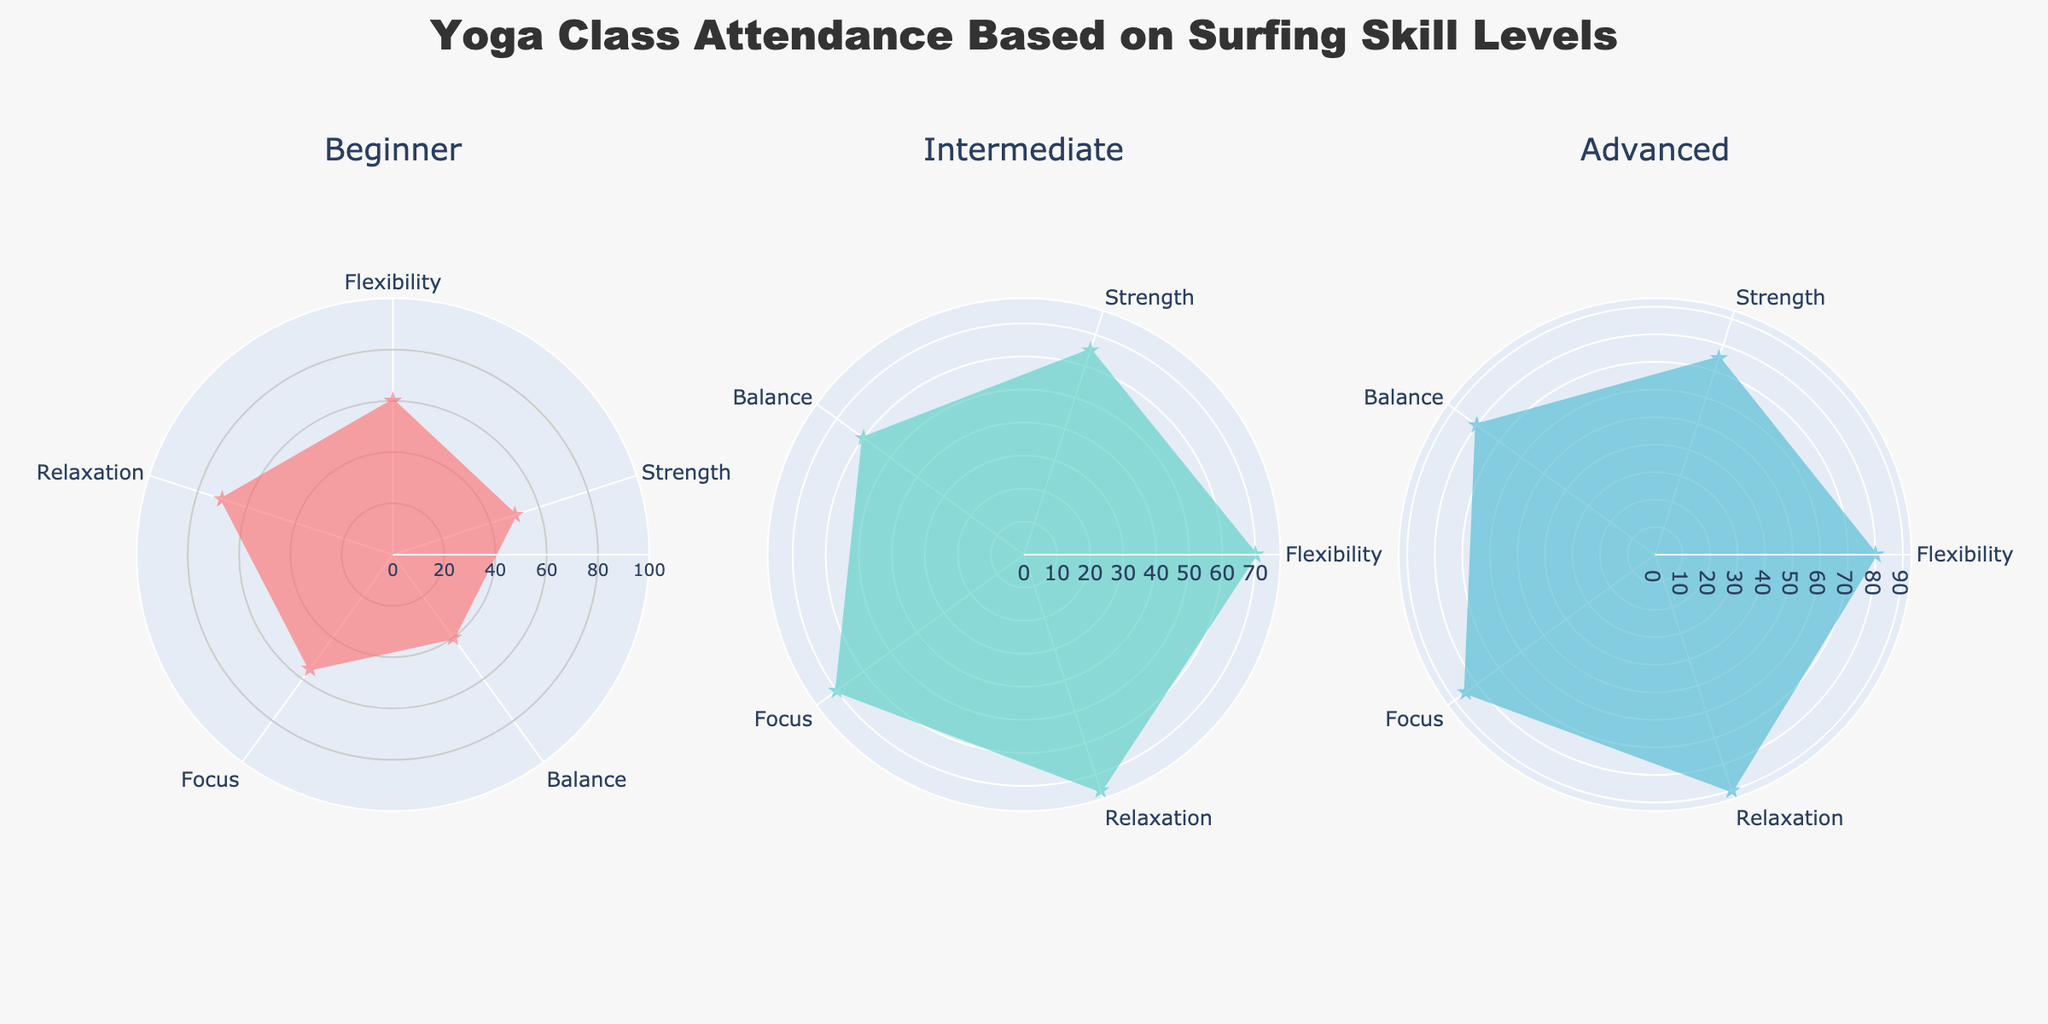What are the five categories being measured in the radar charts? The radar charts have five axes labeled as Flexibility, Strength, Balance, Focus, and Relaxation, which represent the categories being measured for yoga class attendance.
Answer: Flexibility, Strength, Balance, Focus, Relaxation How do the Flexibility scores compare across different surfing skill levels? The Flexibility scores for the skill levels are represented on the radial axes. Beginners have a score of 60, Intermediates have a score of 70, and Advanced surfers have a score of 80.
Answer: Beginner: 60, Intermediate: 70, Advanced: 80 Which skill level shows the highest score in Balance? By examining the Balance axis on the radar chart, we see that the scores are 40 for Beginners, 60 for Intermediates, and 80 for Advanced surfers. The Advanced skill level has the highest score.
Answer: Advanced What is the average Strength score across all skill levels? To calculate the average Strength score, sum the Strength scores for each skill level (50 for Beginners, 65 for Intermediates, and 75 for Advanced) and divide by the number of skill levels (3). Average = (50 + 65 + 75) / 3 = 190 / 3.
Answer: 63.33 Between Intermediates and Advanced surfers, which group shows a higher overall average score across all categories? First, calculate the average scores: Intermediate (70+65+60+70+75)/5 = 68; Advanced (80+75+80+85+90)/5 = 82. The Advanced group has a higher overall average score.
Answer: Advanced How does Focus compare between Beginners and Intermediates? Comparing the Focus scores directly from the radar chart, Beginners have a score of 55, while Intermediates have a score of 70. Intermediates score higher in Focus than Beginners.
Answer: Intermediates What is the total score for Relaxation across all skill levels? The Relaxation scores are 70 for Beginners, 75 for Intermediates, and 90 for Advanced. Summing these gives: 70 + 75 + 90 = 235.
Answer: 235 Which category shows the most significant difference in scores between Beginners and Advanced surfers? Calculate the differences for each category: Flexibility (80-60=20), Strength (75-50=25), Balance (80-40=40), Focus (85-55=30), Relaxation (90-70=20). Balance has the most significant difference of 40 points.
Answer: Balance Is the relative trend in scores consistent across all categories as skill level increases? Observing the radar chart, all scores consistently increase in value from Beginner to Intermediate to Advanced across all categories.
Answer: Yes 